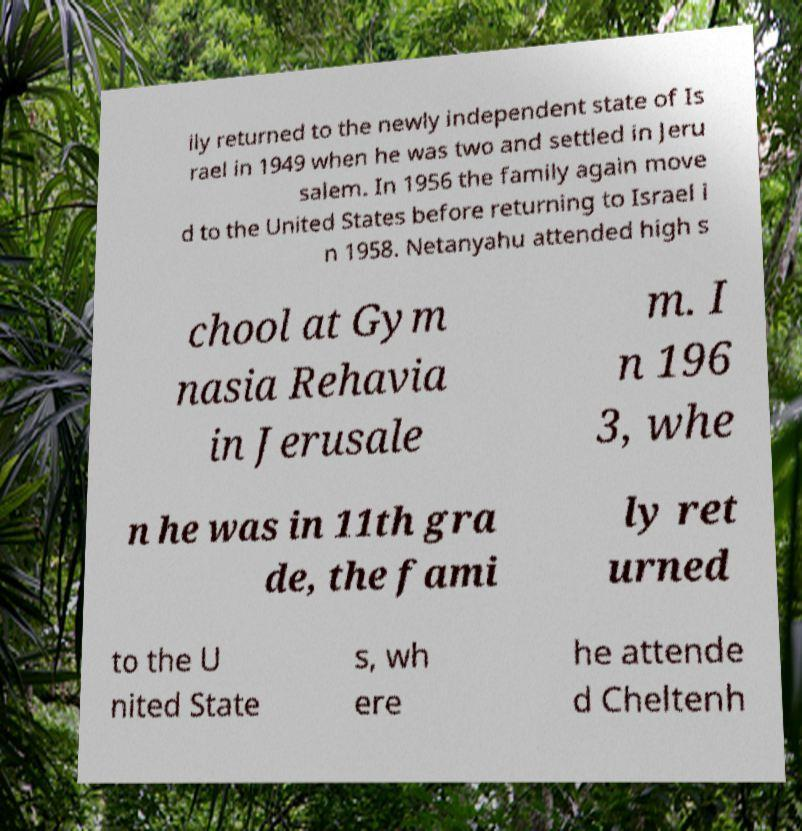I need the written content from this picture converted into text. Can you do that? ily returned to the newly independent state of Is rael in 1949 when he was two and settled in Jeru salem. In 1956 the family again move d to the United States before returning to Israel i n 1958. Netanyahu attended high s chool at Gym nasia Rehavia in Jerusale m. I n 196 3, whe n he was in 11th gra de, the fami ly ret urned to the U nited State s, wh ere he attende d Cheltenh 